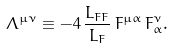<formula> <loc_0><loc_0><loc_500><loc_500>\Lambda ^ { \mu \nu } \equiv - 4 \, \frac { L _ { F F } } { L _ { F } } \, F ^ { \mu \alpha } \, F _ { \alpha } ^ { \nu } .</formula> 